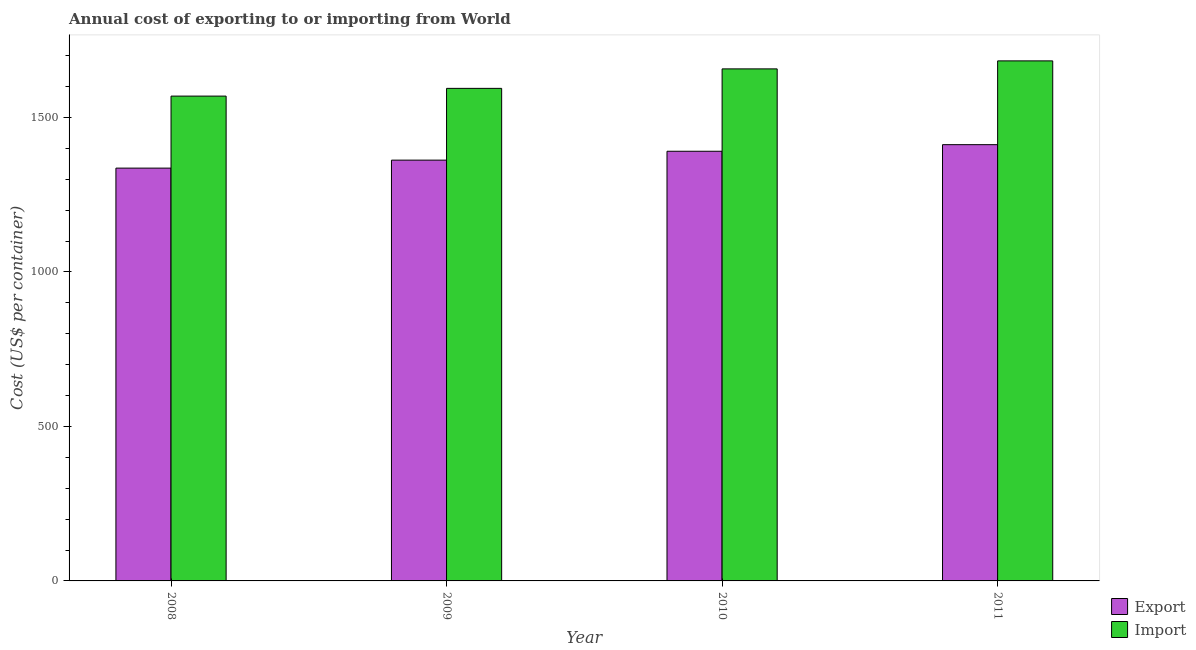Are the number of bars per tick equal to the number of legend labels?
Make the answer very short. Yes. Are the number of bars on each tick of the X-axis equal?
Offer a terse response. Yes. How many bars are there on the 1st tick from the left?
Provide a succinct answer. 2. How many bars are there on the 4th tick from the right?
Provide a succinct answer. 2. What is the label of the 2nd group of bars from the left?
Provide a succinct answer. 2009. In how many cases, is the number of bars for a given year not equal to the number of legend labels?
Your answer should be very brief. 0. What is the import cost in 2009?
Give a very brief answer. 1593.96. Across all years, what is the maximum export cost?
Provide a short and direct response. 1411.78. Across all years, what is the minimum import cost?
Keep it short and to the point. 1568.95. In which year was the export cost minimum?
Provide a short and direct response. 2008. What is the total import cost in the graph?
Provide a short and direct response. 6502.86. What is the difference between the import cost in 2008 and that in 2011?
Give a very brief answer. -113.98. What is the difference between the export cost in 2010 and the import cost in 2009?
Make the answer very short. 28.71. What is the average import cost per year?
Your answer should be compact. 1625.72. In how many years, is the import cost greater than 500 US$?
Provide a succinct answer. 4. What is the ratio of the export cost in 2009 to that in 2010?
Your answer should be compact. 0.98. Is the export cost in 2010 less than that in 2011?
Your answer should be very brief. Yes. What is the difference between the highest and the second highest import cost?
Your answer should be very brief. 25.89. What is the difference between the highest and the lowest export cost?
Keep it short and to the point. 75.92. In how many years, is the export cost greater than the average export cost taken over all years?
Offer a terse response. 2. Is the sum of the export cost in 2010 and 2011 greater than the maximum import cost across all years?
Offer a terse response. Yes. What does the 1st bar from the left in 2011 represents?
Offer a very short reply. Export. What does the 2nd bar from the right in 2009 represents?
Your answer should be compact. Export. How many bars are there?
Your answer should be compact. 8. Does the graph contain any zero values?
Offer a very short reply. No. Where does the legend appear in the graph?
Make the answer very short. Bottom right. How many legend labels are there?
Provide a short and direct response. 2. How are the legend labels stacked?
Ensure brevity in your answer.  Vertical. What is the title of the graph?
Your answer should be very brief. Annual cost of exporting to or importing from World. Does "Lower secondary education" appear as one of the legend labels in the graph?
Offer a very short reply. No. What is the label or title of the X-axis?
Keep it short and to the point. Year. What is the label or title of the Y-axis?
Keep it short and to the point. Cost (US$ per container). What is the Cost (US$ per container) in Export in 2008?
Offer a terse response. 1335.86. What is the Cost (US$ per container) of Import in 2008?
Your answer should be compact. 1568.95. What is the Cost (US$ per container) in Export in 2009?
Make the answer very short. 1361.74. What is the Cost (US$ per container) of Import in 2009?
Offer a terse response. 1593.96. What is the Cost (US$ per container) in Export in 2010?
Your answer should be very brief. 1390.45. What is the Cost (US$ per container) of Import in 2010?
Offer a terse response. 1657.04. What is the Cost (US$ per container) in Export in 2011?
Your response must be concise. 1411.78. What is the Cost (US$ per container) of Import in 2011?
Provide a succinct answer. 1682.92. Across all years, what is the maximum Cost (US$ per container) in Export?
Keep it short and to the point. 1411.78. Across all years, what is the maximum Cost (US$ per container) in Import?
Offer a terse response. 1682.92. Across all years, what is the minimum Cost (US$ per container) of Export?
Ensure brevity in your answer.  1335.86. Across all years, what is the minimum Cost (US$ per container) of Import?
Your answer should be compact. 1568.95. What is the total Cost (US$ per container) in Export in the graph?
Keep it short and to the point. 5499.83. What is the total Cost (US$ per container) of Import in the graph?
Offer a very short reply. 6502.86. What is the difference between the Cost (US$ per container) in Export in 2008 and that in 2009?
Provide a succinct answer. -25.88. What is the difference between the Cost (US$ per container) of Import in 2008 and that in 2009?
Your response must be concise. -25.01. What is the difference between the Cost (US$ per container) of Export in 2008 and that in 2010?
Make the answer very short. -54.59. What is the difference between the Cost (US$ per container) in Import in 2008 and that in 2010?
Your response must be concise. -88.09. What is the difference between the Cost (US$ per container) in Export in 2008 and that in 2011?
Provide a short and direct response. -75.92. What is the difference between the Cost (US$ per container) in Import in 2008 and that in 2011?
Ensure brevity in your answer.  -113.98. What is the difference between the Cost (US$ per container) of Export in 2009 and that in 2010?
Provide a succinct answer. -28.71. What is the difference between the Cost (US$ per container) in Import in 2009 and that in 2010?
Your response must be concise. -63.08. What is the difference between the Cost (US$ per container) of Export in 2009 and that in 2011?
Make the answer very short. -50.04. What is the difference between the Cost (US$ per container) in Import in 2009 and that in 2011?
Offer a very short reply. -88.97. What is the difference between the Cost (US$ per container) in Export in 2010 and that in 2011?
Give a very brief answer. -21.33. What is the difference between the Cost (US$ per container) in Import in 2010 and that in 2011?
Your response must be concise. -25.89. What is the difference between the Cost (US$ per container) of Export in 2008 and the Cost (US$ per container) of Import in 2009?
Your response must be concise. -258.09. What is the difference between the Cost (US$ per container) of Export in 2008 and the Cost (US$ per container) of Import in 2010?
Your answer should be very brief. -321.18. What is the difference between the Cost (US$ per container) in Export in 2008 and the Cost (US$ per container) in Import in 2011?
Ensure brevity in your answer.  -347.06. What is the difference between the Cost (US$ per container) in Export in 2009 and the Cost (US$ per container) in Import in 2010?
Offer a terse response. -295.3. What is the difference between the Cost (US$ per container) in Export in 2009 and the Cost (US$ per container) in Import in 2011?
Your answer should be very brief. -321.19. What is the difference between the Cost (US$ per container) of Export in 2010 and the Cost (US$ per container) of Import in 2011?
Keep it short and to the point. -292.48. What is the average Cost (US$ per container) of Export per year?
Your response must be concise. 1374.96. What is the average Cost (US$ per container) of Import per year?
Keep it short and to the point. 1625.72. In the year 2008, what is the difference between the Cost (US$ per container) in Export and Cost (US$ per container) in Import?
Your answer should be very brief. -233.08. In the year 2009, what is the difference between the Cost (US$ per container) of Export and Cost (US$ per container) of Import?
Keep it short and to the point. -232.22. In the year 2010, what is the difference between the Cost (US$ per container) in Export and Cost (US$ per container) in Import?
Give a very brief answer. -266.59. In the year 2011, what is the difference between the Cost (US$ per container) of Export and Cost (US$ per container) of Import?
Keep it short and to the point. -271.15. What is the ratio of the Cost (US$ per container) in Export in 2008 to that in 2009?
Offer a terse response. 0.98. What is the ratio of the Cost (US$ per container) in Import in 2008 to that in 2009?
Your answer should be very brief. 0.98. What is the ratio of the Cost (US$ per container) of Export in 2008 to that in 2010?
Your response must be concise. 0.96. What is the ratio of the Cost (US$ per container) of Import in 2008 to that in 2010?
Give a very brief answer. 0.95. What is the ratio of the Cost (US$ per container) of Export in 2008 to that in 2011?
Your answer should be compact. 0.95. What is the ratio of the Cost (US$ per container) in Import in 2008 to that in 2011?
Your answer should be compact. 0.93. What is the ratio of the Cost (US$ per container) in Export in 2009 to that in 2010?
Provide a succinct answer. 0.98. What is the ratio of the Cost (US$ per container) in Import in 2009 to that in 2010?
Your response must be concise. 0.96. What is the ratio of the Cost (US$ per container) in Export in 2009 to that in 2011?
Keep it short and to the point. 0.96. What is the ratio of the Cost (US$ per container) of Import in 2009 to that in 2011?
Make the answer very short. 0.95. What is the ratio of the Cost (US$ per container) of Export in 2010 to that in 2011?
Ensure brevity in your answer.  0.98. What is the ratio of the Cost (US$ per container) of Import in 2010 to that in 2011?
Provide a succinct answer. 0.98. What is the difference between the highest and the second highest Cost (US$ per container) in Export?
Ensure brevity in your answer.  21.33. What is the difference between the highest and the second highest Cost (US$ per container) in Import?
Your answer should be very brief. 25.89. What is the difference between the highest and the lowest Cost (US$ per container) in Export?
Offer a terse response. 75.92. What is the difference between the highest and the lowest Cost (US$ per container) in Import?
Offer a very short reply. 113.98. 